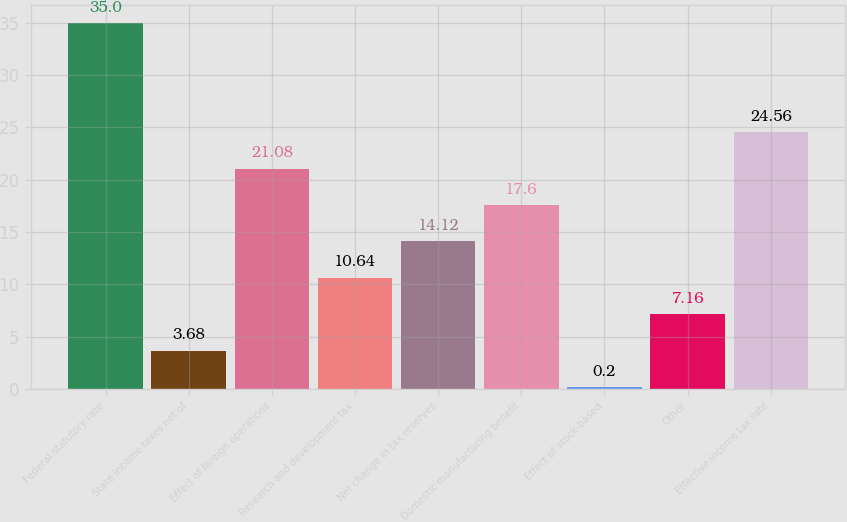Convert chart to OTSL. <chart><loc_0><loc_0><loc_500><loc_500><bar_chart><fcel>Federal statutory rate<fcel>State income taxes net of<fcel>Effect of foreign operations<fcel>Research and development tax<fcel>Net change in tax reserves<fcel>Domestic manufacturing benefit<fcel>Effect of stock-based<fcel>Other<fcel>Effective income tax rate<nl><fcel>35<fcel>3.68<fcel>21.08<fcel>10.64<fcel>14.12<fcel>17.6<fcel>0.2<fcel>7.16<fcel>24.56<nl></chart> 